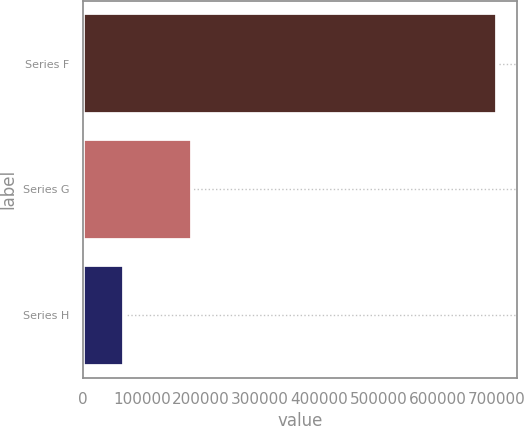Convert chart to OTSL. <chart><loc_0><loc_0><loc_500><loc_500><bar_chart><fcel>Series F<fcel>Series G<fcel>Series H<nl><fcel>700000<fcel>184000<fcel>70000<nl></chart> 